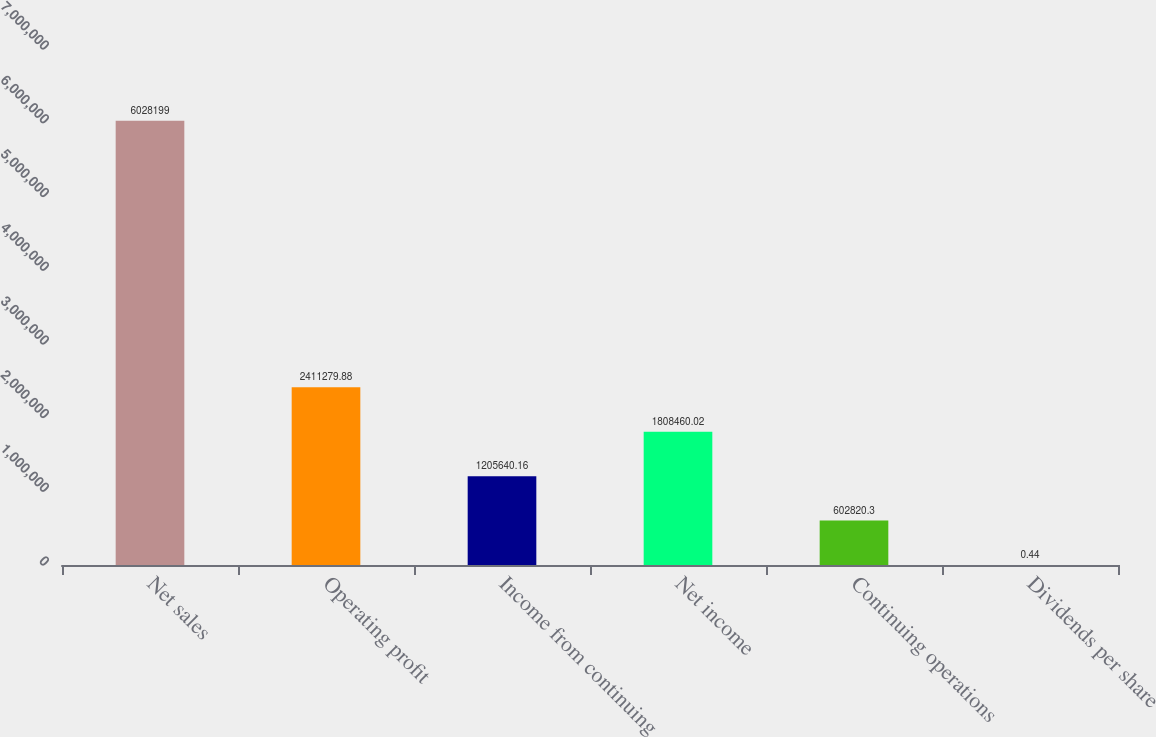Convert chart to OTSL. <chart><loc_0><loc_0><loc_500><loc_500><bar_chart><fcel>Net sales<fcel>Operating profit<fcel>Income from continuing<fcel>Net income<fcel>Continuing operations<fcel>Dividends per share<nl><fcel>6.0282e+06<fcel>2.41128e+06<fcel>1.20564e+06<fcel>1.80846e+06<fcel>602820<fcel>0.44<nl></chart> 